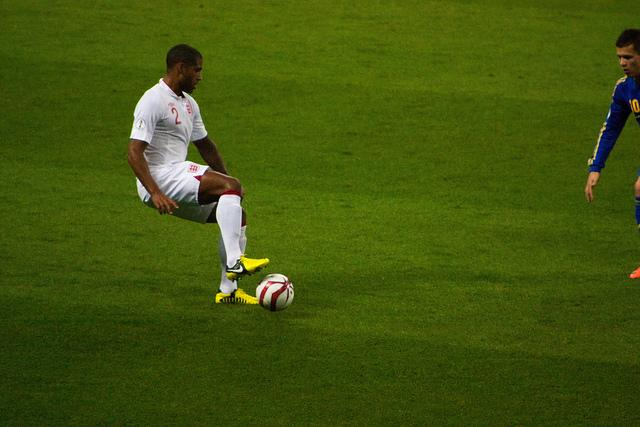The man with the ball has shoes that have a majority color that matches the color of what? banana 